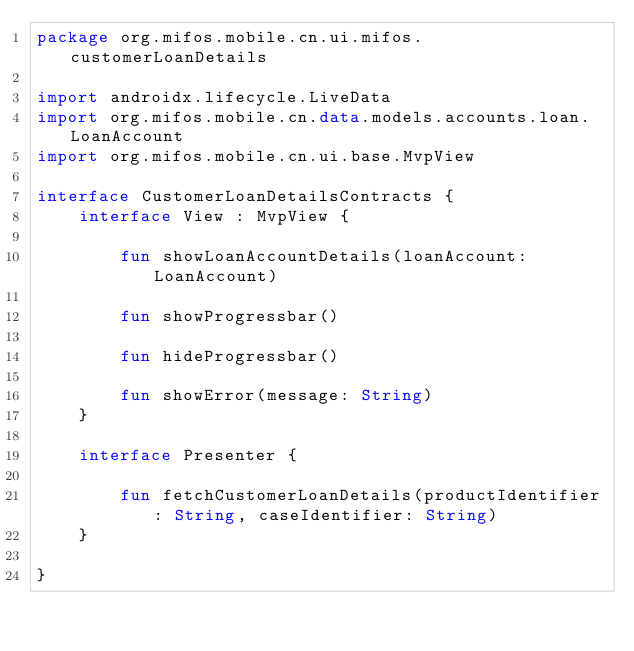<code> <loc_0><loc_0><loc_500><loc_500><_Kotlin_>package org.mifos.mobile.cn.ui.mifos.customerLoanDetails

import androidx.lifecycle.LiveData
import org.mifos.mobile.cn.data.models.accounts.loan.LoanAccount
import org.mifos.mobile.cn.ui.base.MvpView

interface CustomerLoanDetailsContracts {
    interface View : MvpView {

        fun showLoanAccountDetails(loanAccount: LoanAccount)

        fun showProgressbar()

        fun hideProgressbar()

        fun showError(message: String)
    }

    interface Presenter {

        fun fetchCustomerLoanDetails(productIdentifier: String, caseIdentifier: String)
    }

}</code> 